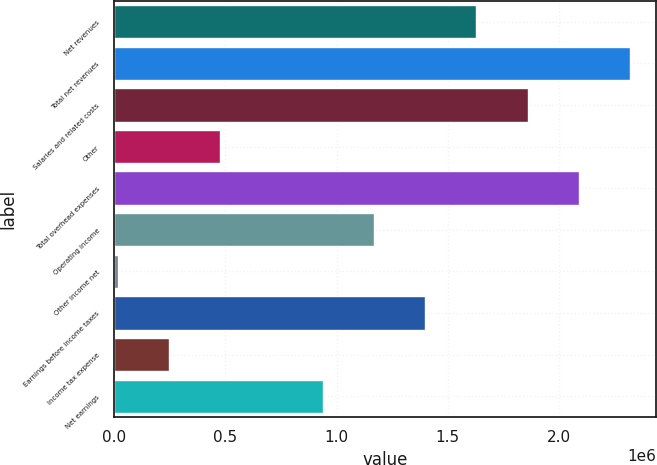<chart> <loc_0><loc_0><loc_500><loc_500><bar_chart><fcel>Net revenues<fcel>Total net revenues<fcel>Salaries and related costs<fcel>Other<fcel>Total overhead expenses<fcel>Operating income<fcel>Other income net<fcel>Earnings before income taxes<fcel>Income tax expense<fcel>Net earnings<nl><fcel>1.62893e+06<fcel>2.31919e+06<fcel>1.85902e+06<fcel>478506<fcel>2.0891e+06<fcel>1.16876e+06<fcel>18335<fcel>1.39885e+06<fcel>248420<fcel>938677<nl></chart> 